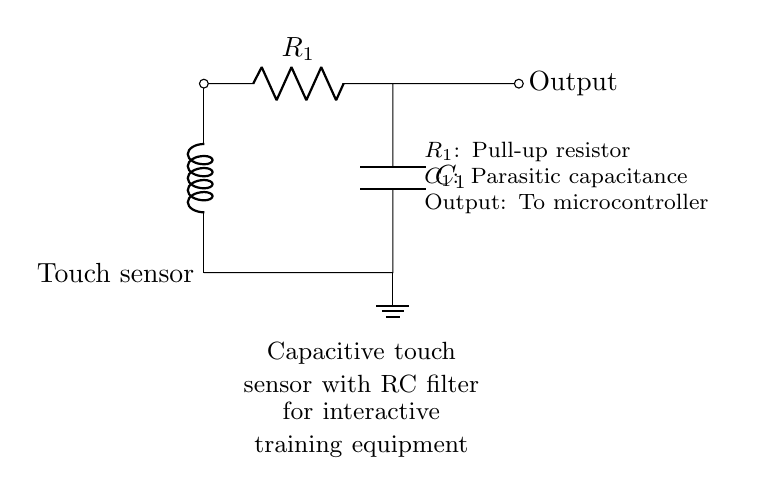What is the pull-up resistor labeled in the circuit? The pull-up resistor is labeled as R1, which is indicated directly next to it in the diagram.
Answer: R1 What type of sensor is used in this circuit? The circuit uses a capacitive touch sensor, which is explicitly mentioned at the left side of the circuit diagram.
Answer: Capacitive touch sensor What does the capacitor represent in this circuit? The capacitor is represented as C1, which we can identify alongside its labeling. It serves as a parasitic capacitance in the RC filter setup.
Answer: C1 What is the role of the output in this circuit? The output connects to a microcontroller, shown by the line extending to the right with the label "Output". This indicates it provides a signal to a higher-level control system.
Answer: To microcontroller How are the touch sensor and the RC filter connected? The touch sensor is connected to the top of the resistor (R1), which then connects to the capacitor (C1) at one end and provides the output at the top. This shows a direct series connection.
Answer: In series What happens to the voltage when the touch sensor is activated? When activated, the touch sensor momentarily changes the voltage across the capacitor, which is smoothed by the RC filter, leading to a voltage signal that can be interpreted by the microcontroller. This involves a response time governed by the RC time constant.
Answer: Voltage changes What does the term “parasitic capacitance” imply in this context? Parasitic capacitance refers to the undesired capacitance that exists within circuit components and can affect the performance of the circuit. In this case, C1 represents this capacitance that impacts the charge and discharge times in the RC filter.
Answer: Undesired capacitance 